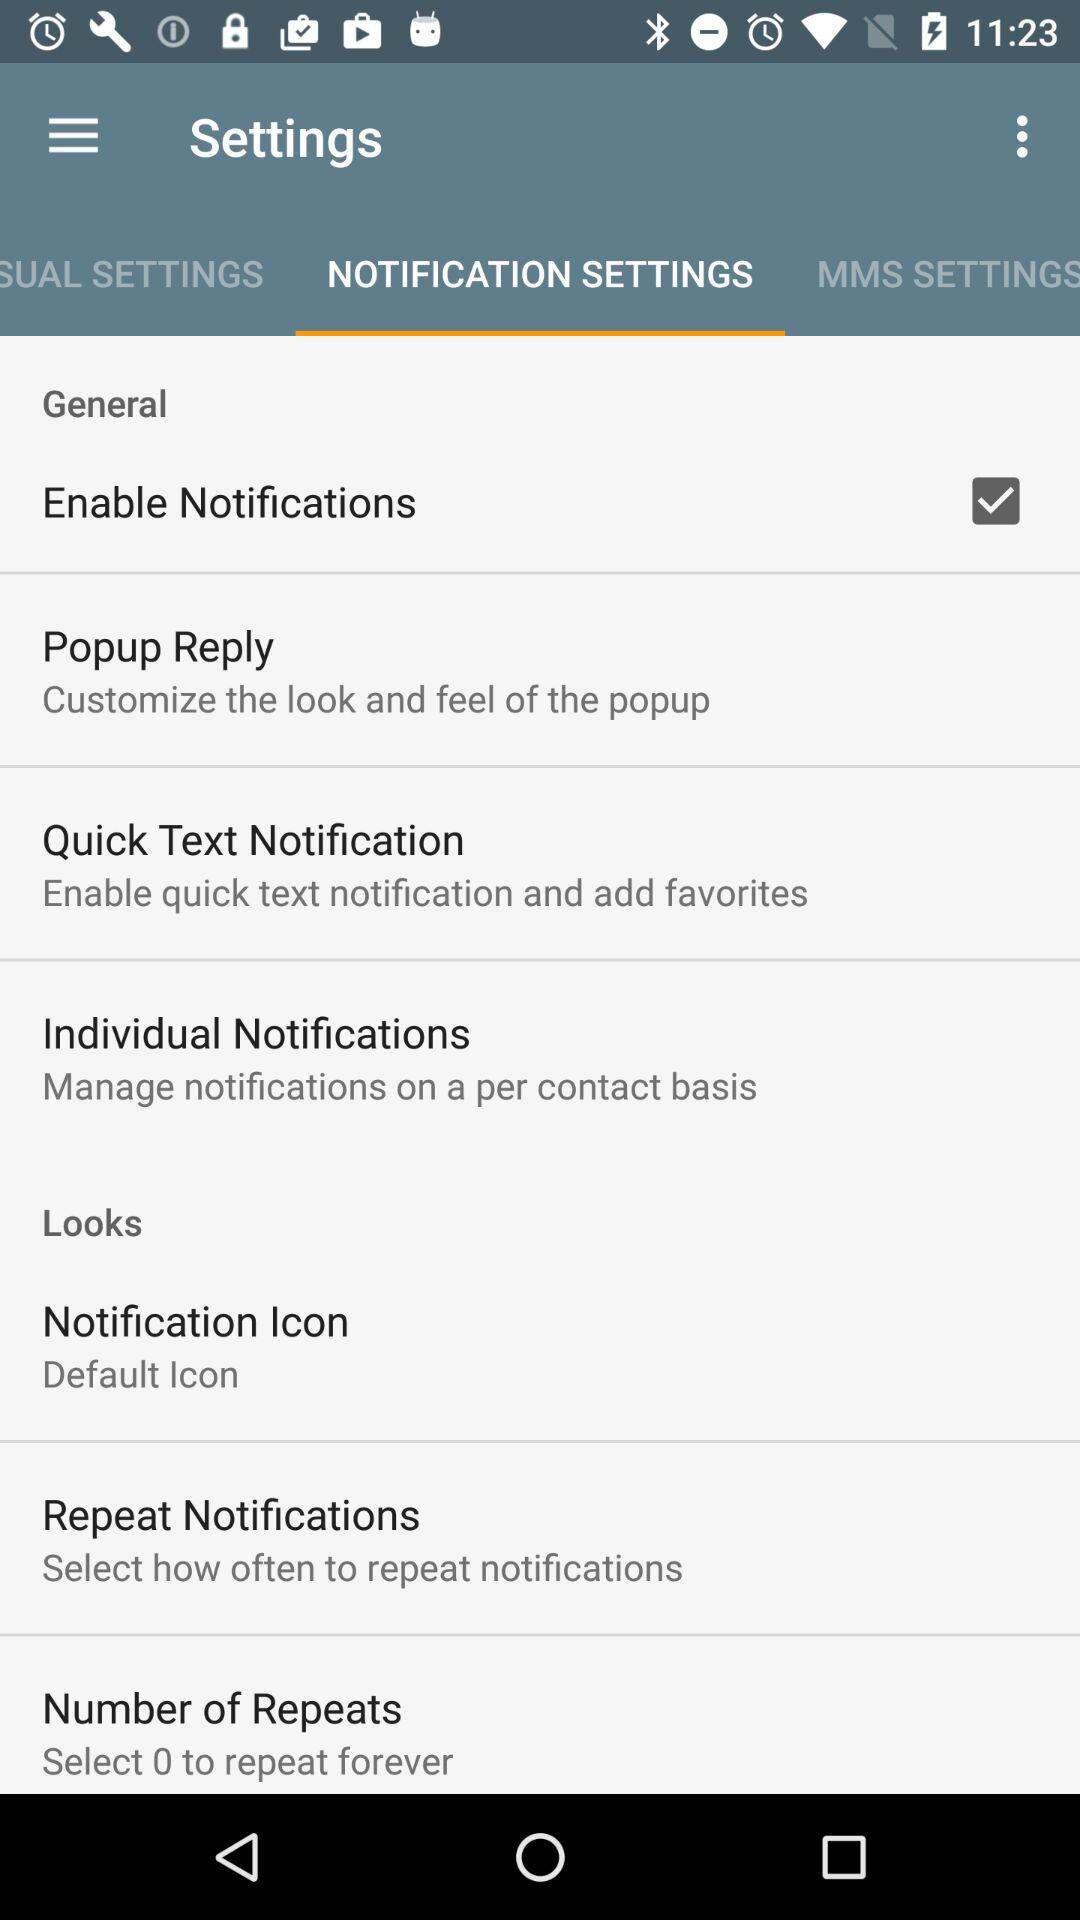How many items are in the 'looks' section?
Answer the question using a single word or phrase. 3 